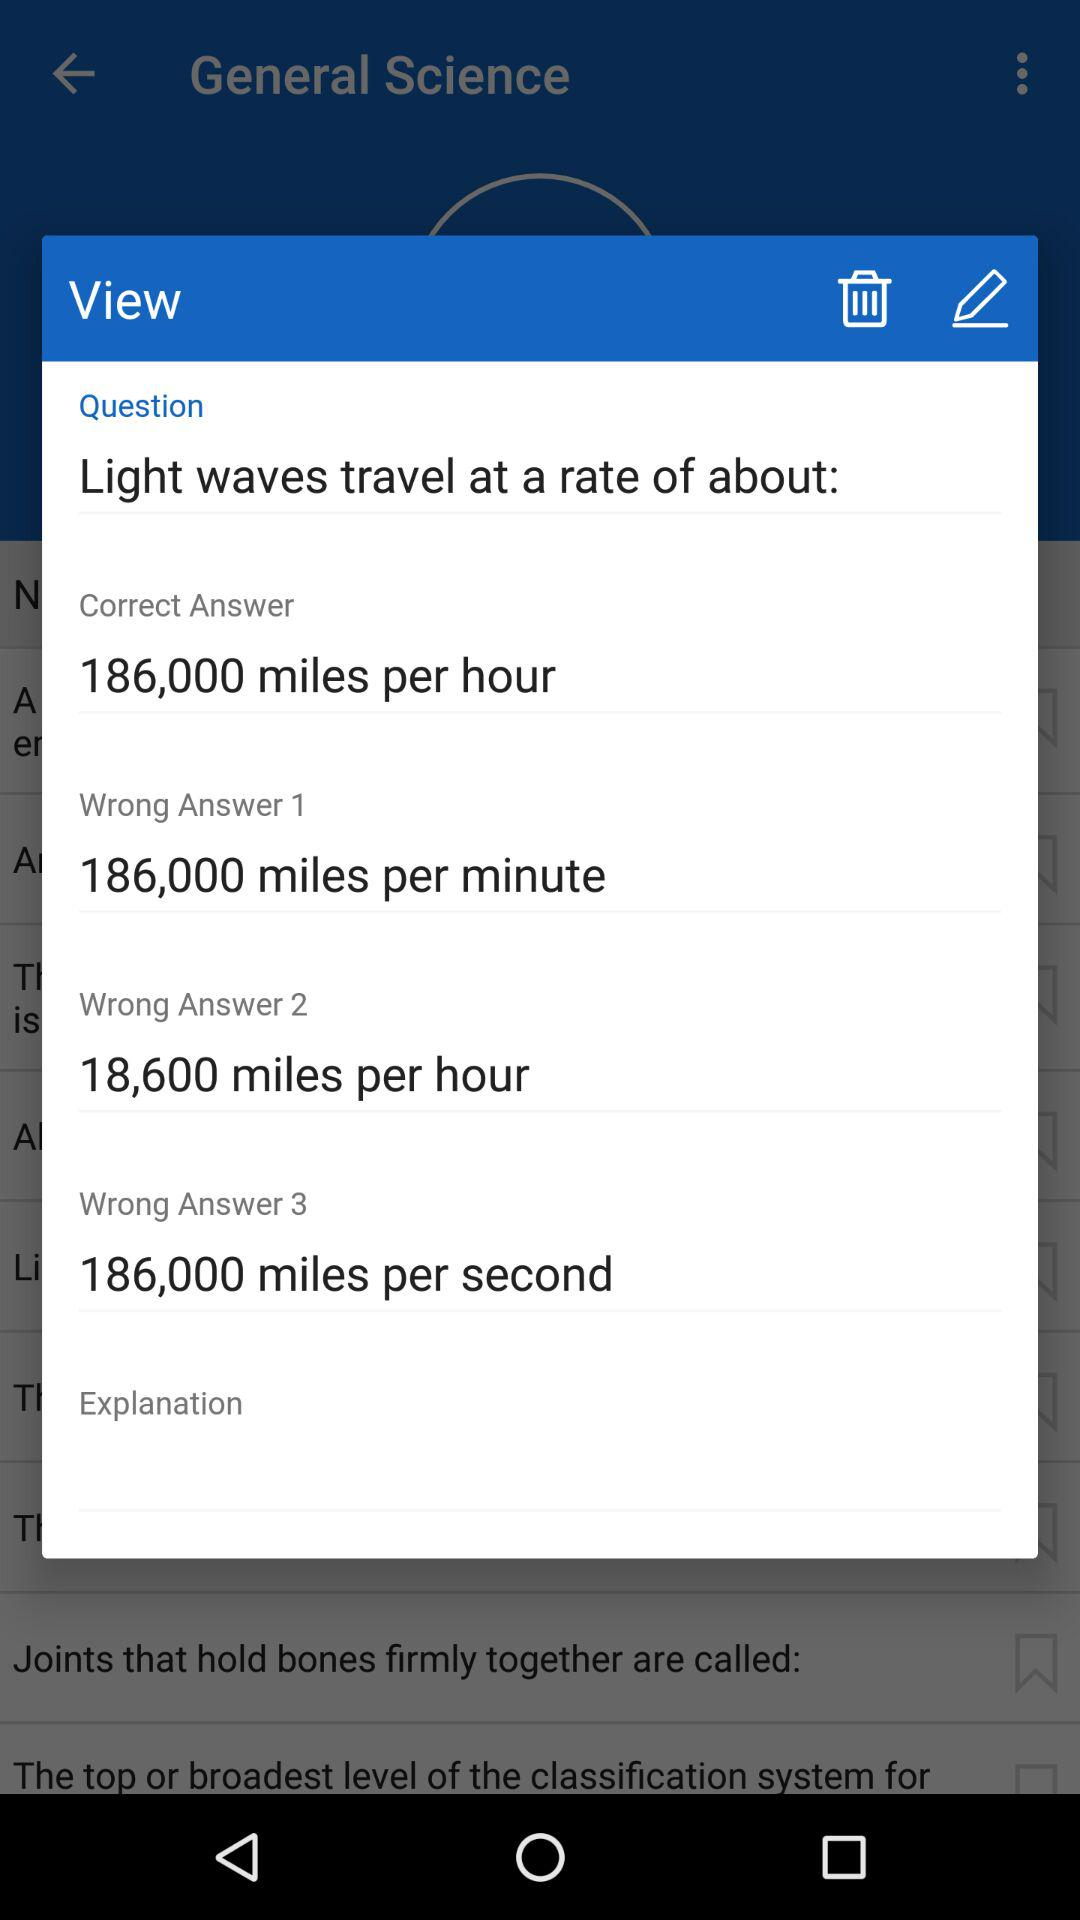What is the "Wrong Answer 2"? The "Wrong Answer 2" is 18,600 miles per hour. 